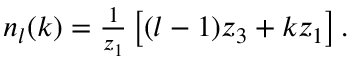<formula> <loc_0><loc_0><loc_500><loc_500>\begin{array} { r } { n _ { l } ( k ) = \frac { 1 } { z _ { 1 } } \left [ ( l - 1 ) z _ { 3 } + k z _ { 1 } \right ] . } \end{array}</formula> 